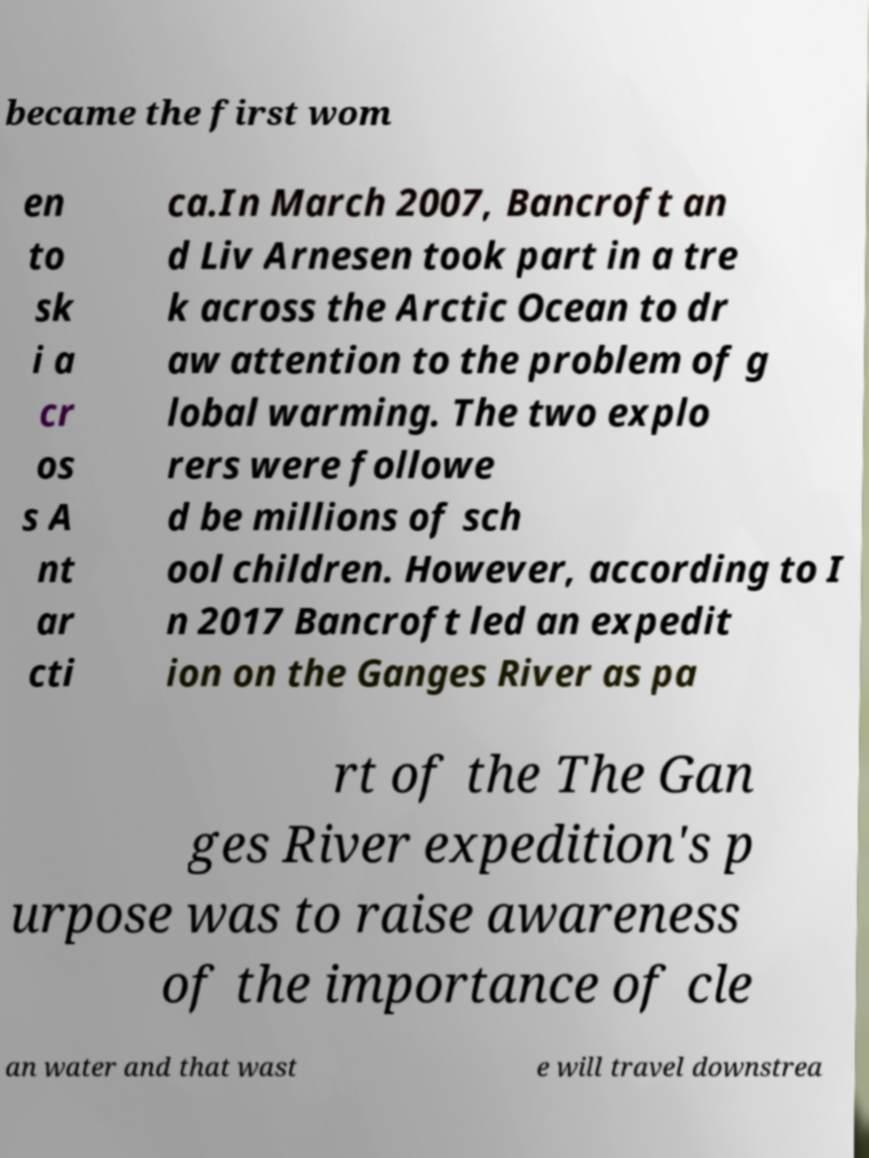Can you accurately transcribe the text from the provided image for me? became the first wom en to sk i a cr os s A nt ar cti ca.In March 2007, Bancroft an d Liv Arnesen took part in a tre k across the Arctic Ocean to dr aw attention to the problem of g lobal warming. The two explo rers were followe d be millions of sch ool children. However, according to I n 2017 Bancroft led an expedit ion on the Ganges River as pa rt of the The Gan ges River expedition's p urpose was to raise awareness of the importance of cle an water and that wast e will travel downstrea 